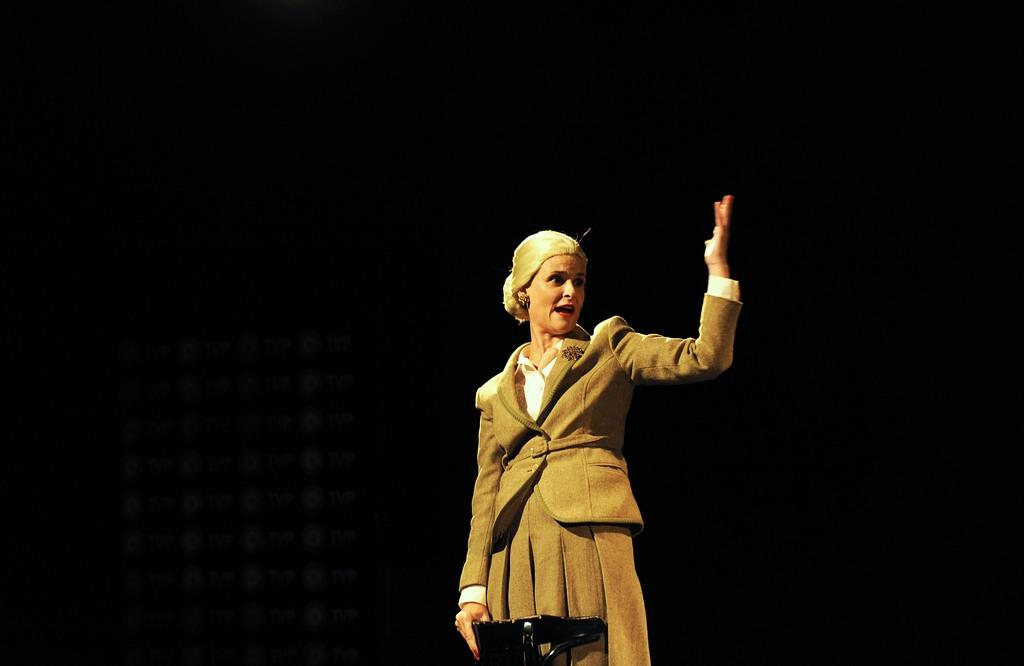Who is the main subject in the image? There is a lady in the image. What is the lady doing in the image? The lady is holding an object and standing. What can be observed about the background of the image? The background of the image is dark. What verse can be heard being recited by the lady in the image? There is no indication in the image that the lady is reciting a verse, so it cannot be determined from the picture. 